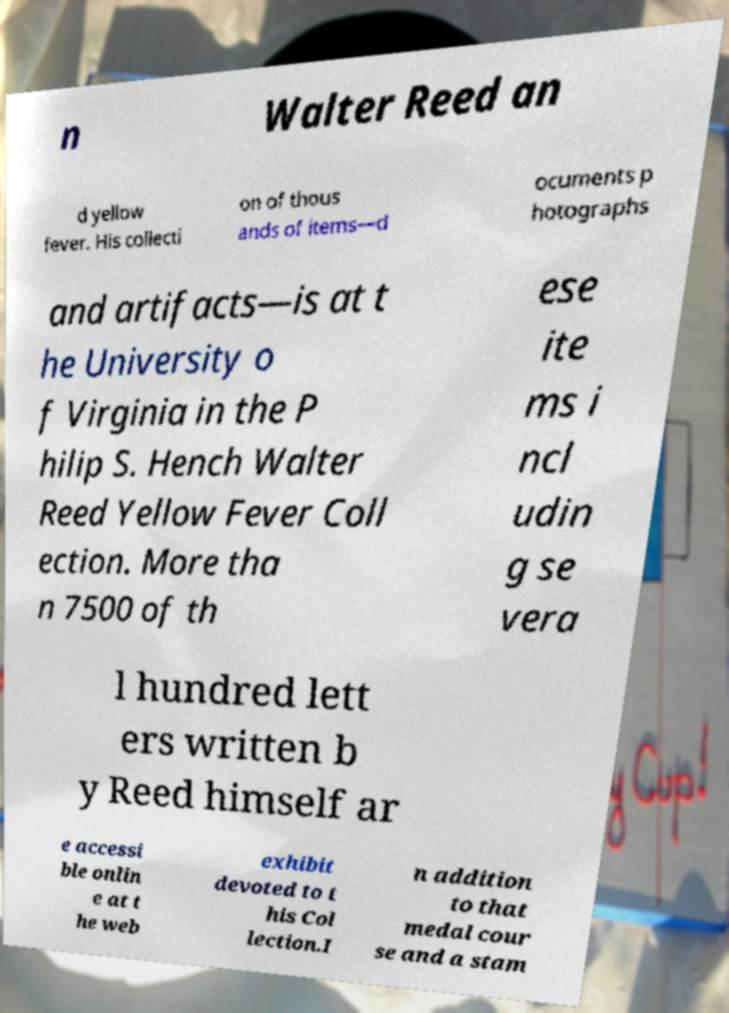There's text embedded in this image that I need extracted. Can you transcribe it verbatim? n Walter Reed an d yellow fever. His collecti on of thous ands of items—d ocuments p hotographs and artifacts—is at t he University o f Virginia in the P hilip S. Hench Walter Reed Yellow Fever Coll ection. More tha n 7500 of th ese ite ms i ncl udin g se vera l hundred lett ers written b y Reed himself ar e accessi ble onlin e at t he web exhibit devoted to t his Col lection.I n addition to that medal cour se and a stam 